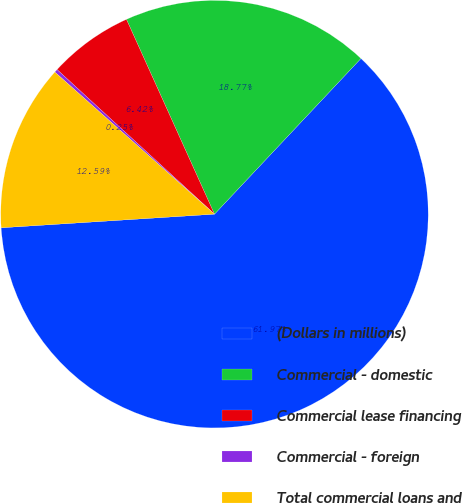Convert chart. <chart><loc_0><loc_0><loc_500><loc_500><pie_chart><fcel>(Dollars in millions)<fcel>Commercial - domestic<fcel>Commercial lease financing<fcel>Commercial - foreign<fcel>Total commercial loans and<nl><fcel>61.97%<fcel>18.77%<fcel>6.42%<fcel>0.25%<fcel>12.59%<nl></chart> 